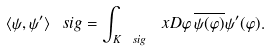Convert formula to latex. <formula><loc_0><loc_0><loc_500><loc_500>\langle \psi , \psi ^ { \prime } \rangle _ { \ } s i g = \int _ { K _ { \ } s i g } \ x D \varphi \, \overline { \psi ( \varphi ) } \psi ^ { \prime } ( \varphi ) .</formula> 